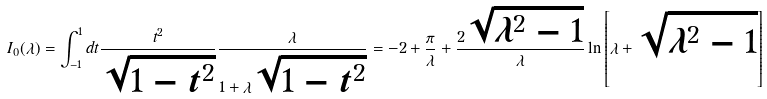<formula> <loc_0><loc_0><loc_500><loc_500>I _ { 0 } ( \lambda ) = \int ^ { 1 } _ { - 1 } d t \frac { t ^ { 2 } } { \sqrt { 1 - t ^ { 2 } } } \frac { \lambda } { 1 + \lambda \sqrt { 1 - t ^ { 2 } } } = - 2 + \frac { \pi } { \lambda } + \frac { 2 \sqrt { \lambda ^ { 2 } - 1 } } { \lambda } \ln \left [ \lambda + \sqrt { \lambda ^ { 2 } - 1 } \right ]</formula> 